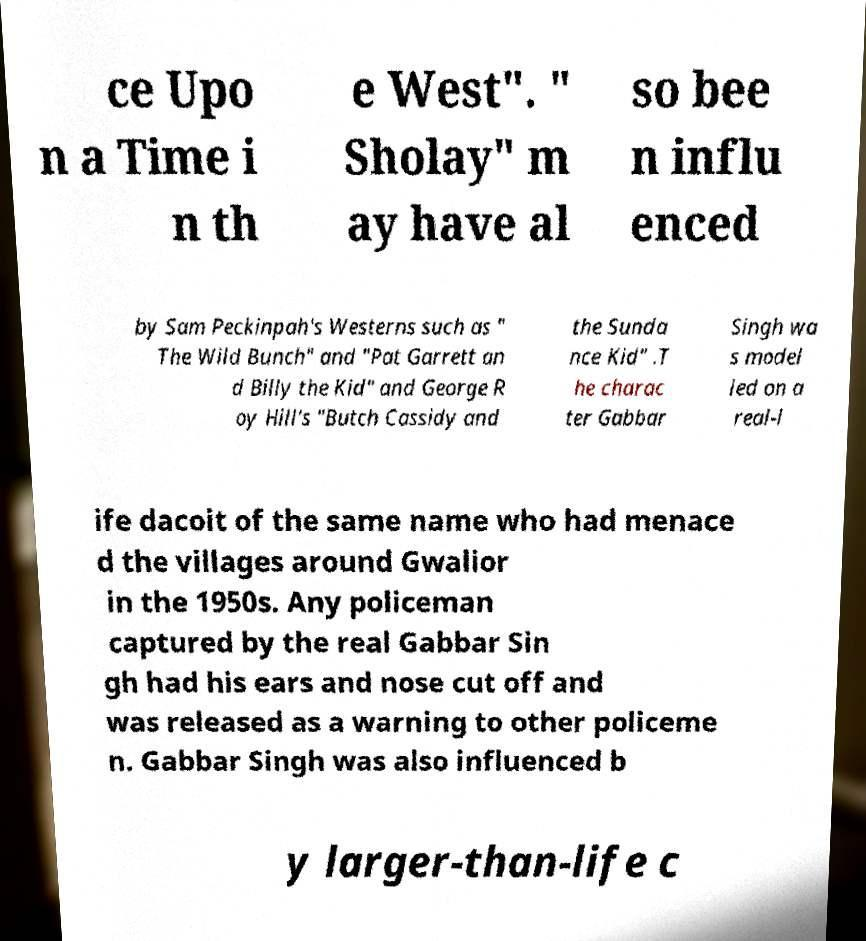Could you assist in decoding the text presented in this image and type it out clearly? ce Upo n a Time i n th e West". " Sholay" m ay have al so bee n influ enced by Sam Peckinpah's Westerns such as " The Wild Bunch" and "Pat Garrett an d Billy the Kid" and George R oy Hill's "Butch Cassidy and the Sunda nce Kid" .T he charac ter Gabbar Singh wa s model led on a real-l ife dacoit of the same name who had menace d the villages around Gwalior in the 1950s. Any policeman captured by the real Gabbar Sin gh had his ears and nose cut off and was released as a warning to other policeme n. Gabbar Singh was also influenced b y larger-than-life c 